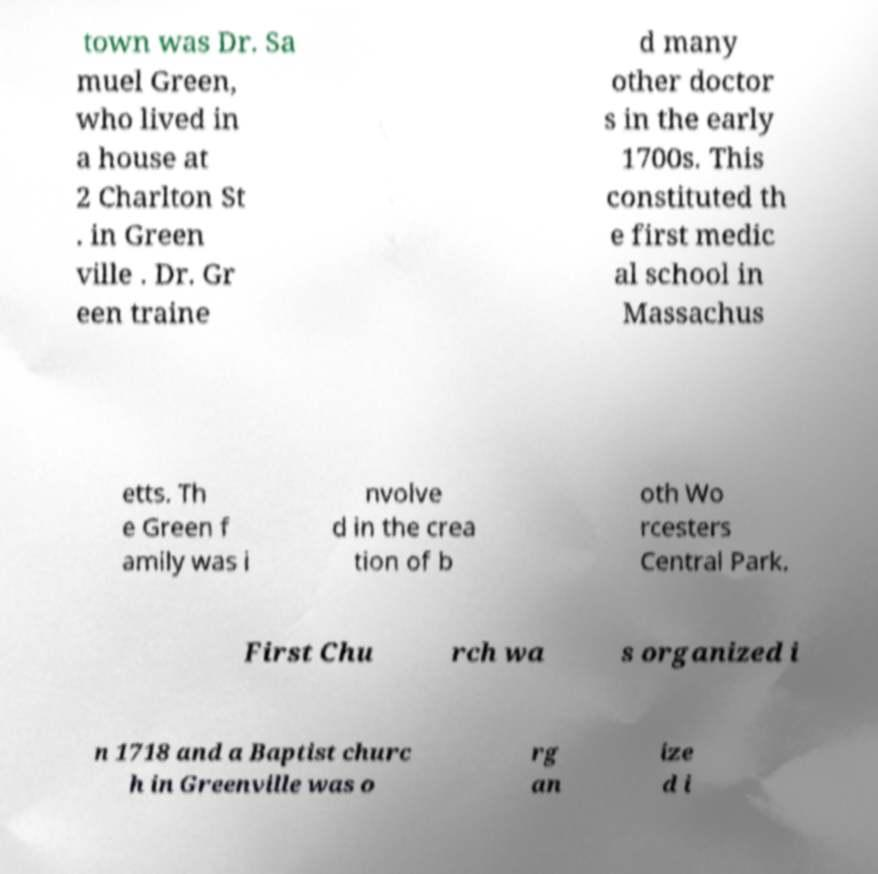There's text embedded in this image that I need extracted. Can you transcribe it verbatim? town was Dr. Sa muel Green, who lived in a house at 2 Charlton St . in Green ville . Dr. Gr een traine d many other doctor s in the early 1700s. This constituted th e first medic al school in Massachus etts. Th e Green f amily was i nvolve d in the crea tion of b oth Wo rcesters Central Park. First Chu rch wa s organized i n 1718 and a Baptist churc h in Greenville was o rg an ize d i 